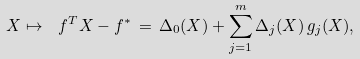Convert formula to latex. <formula><loc_0><loc_0><loc_500><loc_500>X \mapsto \ f ^ { T } X - f ^ { * } \, = \, \Delta _ { 0 } ( X ) + \sum _ { j = 1 } ^ { m } \Delta _ { j } ( X ) \, g _ { j } ( X ) ,</formula> 